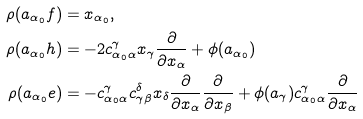<formula> <loc_0><loc_0><loc_500><loc_500>\rho ( a _ { \alpha _ { 0 } } f ) & = x _ { \alpha _ { 0 } } , \\ \rho ( a _ { \alpha _ { 0 } } h ) & = - 2 c _ { \alpha _ { 0 } \alpha } ^ { \gamma } x _ { \gamma } \frac { \partial } { \partial x _ { \alpha } } + \phi ( a _ { \alpha _ { 0 } } ) \\ \rho ( a _ { \alpha _ { 0 } } e ) & = - c _ { \alpha _ { 0 } \alpha } ^ { \gamma } c _ { \gamma \beta } ^ { \delta } x _ { \delta } \frac { \partial } { \partial x _ { \alpha } } \frac { \partial } { \partial x _ { \beta } } + \phi ( a _ { \gamma } ) c _ { \alpha _ { 0 } \alpha } ^ { \gamma } \frac { \partial } { \partial x _ { \alpha } }</formula> 